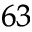Convert formula to latex. <formula><loc_0><loc_0><loc_500><loc_500>^ { 6 3 }</formula> 